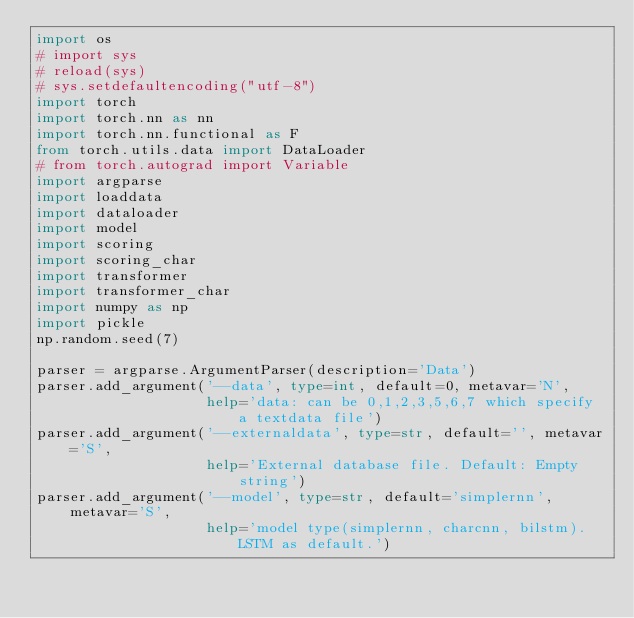<code> <loc_0><loc_0><loc_500><loc_500><_Python_>import os
# import sys
# reload(sys)
# sys.setdefaultencoding("utf-8")
import torch
import torch.nn as nn
import torch.nn.functional as F
from torch.utils.data import DataLoader
# from torch.autograd import Variable
import argparse
import loaddata
import dataloader
import model
import scoring
import scoring_char
import transformer
import transformer_char
import numpy as np
import pickle
np.random.seed(7)

parser = argparse.ArgumentParser(description='Data')
parser.add_argument('--data', type=int, default=0, metavar='N',
                    help='data: can be 0,1,2,3,5,6,7 which specify a textdata file')
parser.add_argument('--externaldata', type=str, default='', metavar='S',
                    help='External database file. Default: Empty string')
parser.add_argument('--model', type=str, default='simplernn', metavar='S',
                    help='model type(simplernn, charcnn, bilstm). LSTM as default.')</code> 